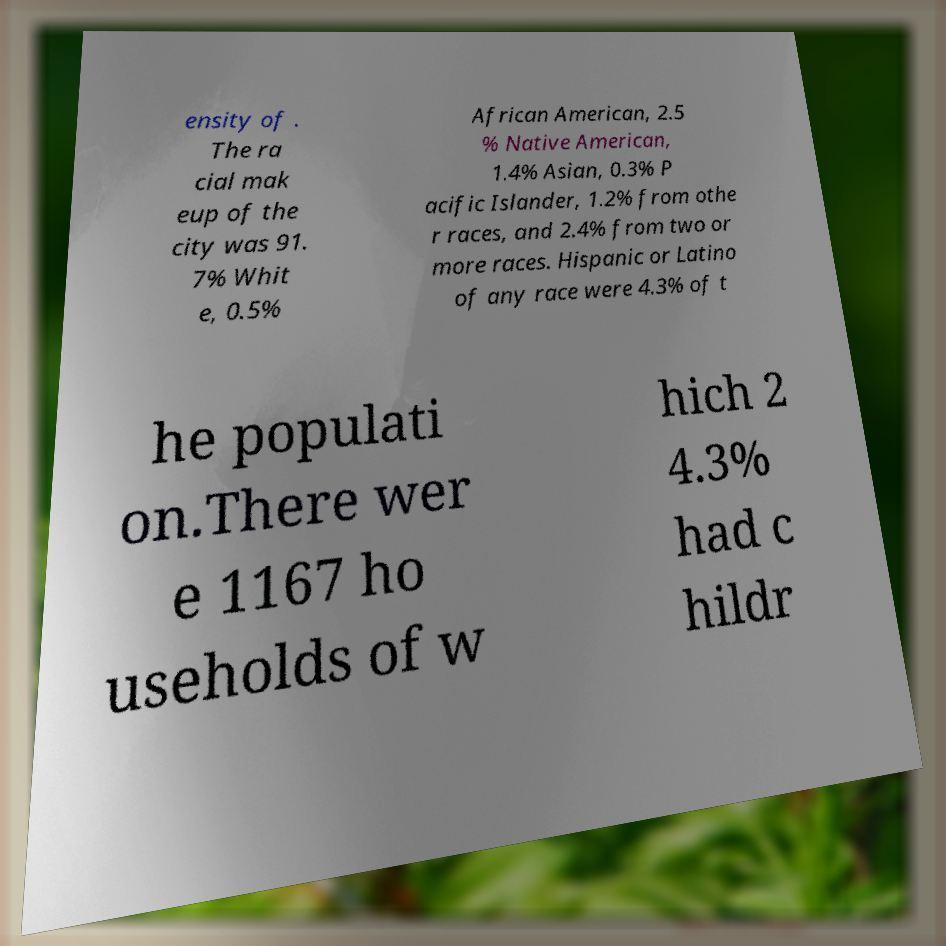Could you extract and type out the text from this image? ensity of . The ra cial mak eup of the city was 91. 7% Whit e, 0.5% African American, 2.5 % Native American, 1.4% Asian, 0.3% P acific Islander, 1.2% from othe r races, and 2.4% from two or more races. Hispanic or Latino of any race were 4.3% of t he populati on.There wer e 1167 ho useholds of w hich 2 4.3% had c hildr 